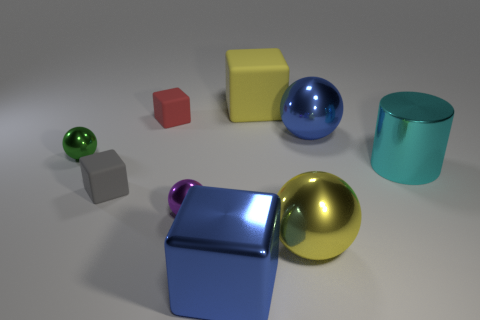What is the shape of the big blue thing on the right side of the big shiny cube? The big blue object on the right side of the large reflective cube is a sphere. Its shiny surface suggests it's likely made of a smooth material that exhibits light-reflecting properties similar to the cube. 